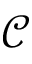<formula> <loc_0><loc_0><loc_500><loc_500>\mathcal { C }</formula> 